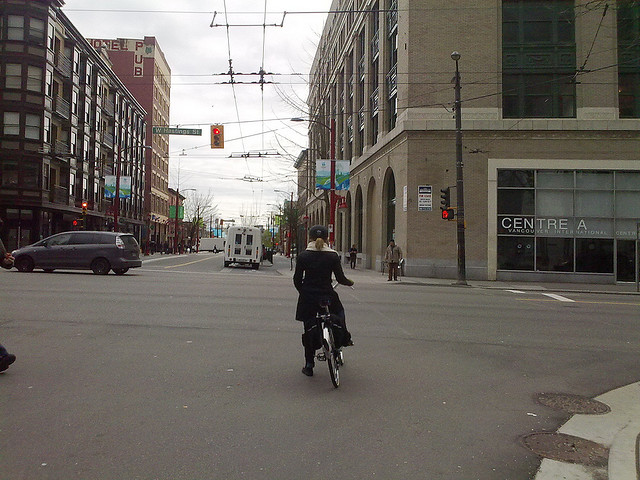Describe the atmosphere of this street. The atmosphere of this street seems calm yet dynamic. Despite the apparent overcast weather, the street exudes a vibrant urban energy typical of a lively city center. The intersection is neat with clear road markings, and various vehicles and pedestrians going about their day contribute to the bustling ambiance. How might this scene change at night? At night, this street likely transforms into a more illuminated and potentially vibrant scene. Streetlights and building lights would cast a warm glow, creating an inviting atmosphere despite the cooler night air. The signage might be more prominent, and additional traffic or nightlife activities could add to the energy. 